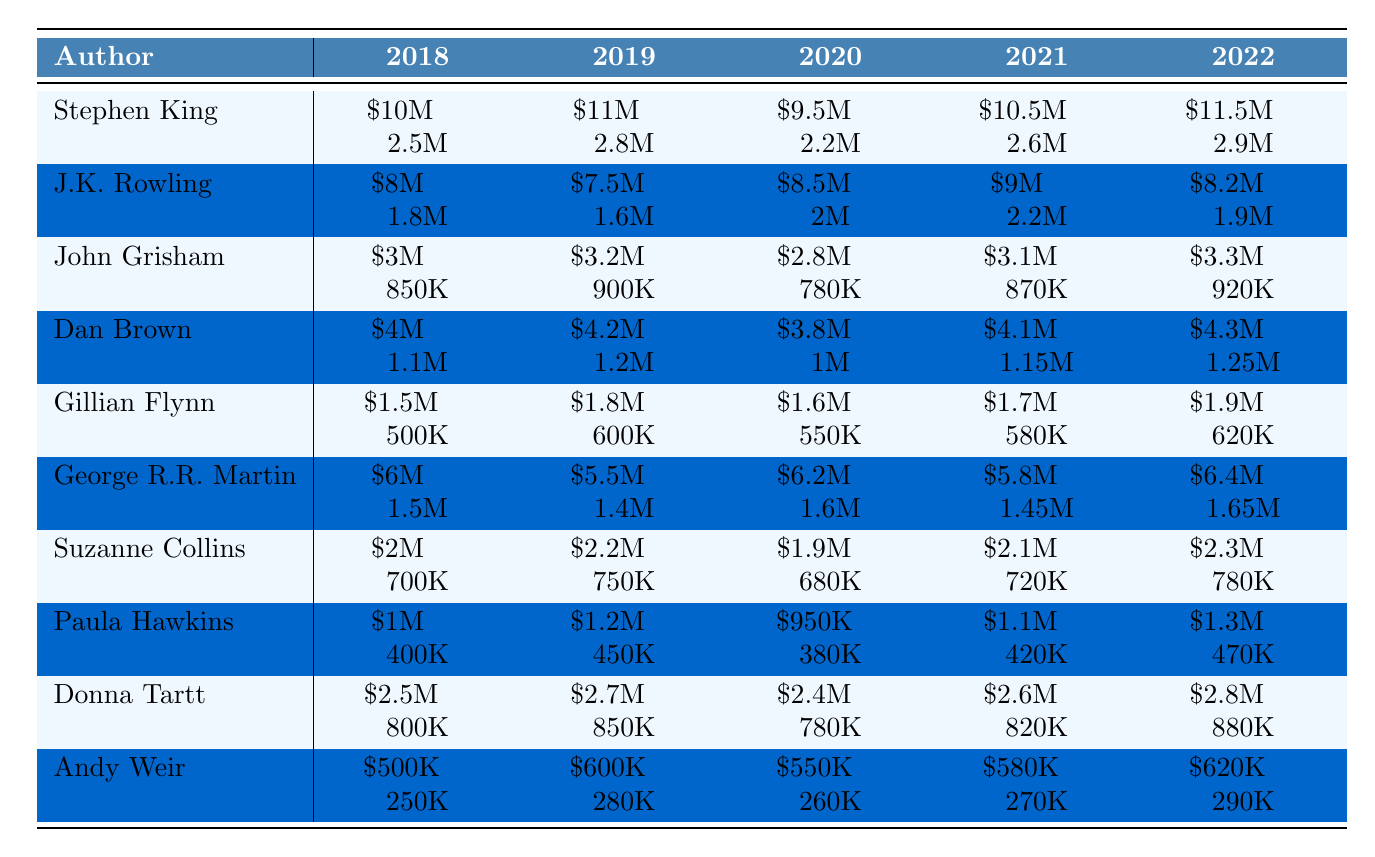What was the advance payment for Stephen King in 2021? From the table, look at the row for Stephen King and find the value for the year 2021. He received an advance of \$10.5 million for that year.
Answer: \$10.5 million Which author had the highest book sales in the year 2020? Review the sales figures for all authors in 2020. From the data, Stephen King had sales of 2.2M, J.K. Rowling had 2M, while others had lower figures. Stephen King had the highest sales in 2020.
Answer: Stephen King What was the total advance payment for J.K. Rowling over the last 5 years? Add the advance payments for J.K. Rowling from 2018 to 2022: \$8M + \$7.5M + \$8.5M + \$9M + \$8.2M = \$41.2 million.
Answer: \$41.2 million Is it true that Dan Brown's book sales increased every year from 2018 to 2022? Check the sales figures for Dan Brown from 2018 to 2022. The sales were 1.1M, 1.2M, 1M, 1.15M, and 1.25M. The figures do not show a consistent increase since they dropped in 2020.
Answer: No What is the average advance payment for all authors in 2022? Calculate the total advances for 2022: \$11.5M + \$8.2M + \$3.3M + \$4.3M + \$1.9M + \$6.4M + \$2.3M + \$1.3M + \$2.8M + \$0.62M = \$40.95 million, then dividing by 10 authors gives \$4.095 million.
Answer: \$4.095 million Which author had the lowest advance payment in 2019? Look at the advance payments for 2019 and find the minimum value. The lowest advance payment for 2019 was for J.K. Rowling at \$7.5 million.
Answer: J.K. Rowling How much did George R.R. Martin earn in advances over the years 2018 to 2022 and what was the rise or decline each year? The advances for George R.R. Martin are \$6M, \$5.5M, \$6.2M, \$5.8M, \$6.4M for 2018-2022. The annual change is decreasing by \$0.5M, increasing by \$0.7M, decreasing by \$0.4M, and increasing by \$0.6M for the years respectively.
Answer: \$6M, -\$0.5M, +\$0.7M, -\$0.4M, +\$0.6M What percentage increase is seen in sales from the lowest number for Gillian Flynn to the highest number in the years presented? Gillian Flynn's sales for the years are: 500K, 600K, 550K, 580K, 620K. The lowest sales were 500K (year 2018) and the highest were 620K (year 2022). The percentage increase is ((620 - 500) / 500) * 100 = 24%.
Answer: 24% Which author had the most consistent advance payments over the 5 years? Review the fluctuation in advances for each author from 2018 to 2022. George R.R. Martin shows relative stability in his advances, ranging from \$5.5M to \$6.4M with minimal yearly variation.
Answer: George R.R. Martin Did the sales figure generally rise for any particular author from 2018 to 2022? Analyze the data for each author to see trends. Suzanne Collins shows an increase in sales from 700K to 780K over the years, indicating a general rise.
Answer: Yes, for Suzanne Collins 